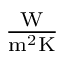Convert formula to latex. <formula><loc_0><loc_0><loc_500><loc_500>{ \frac { W } { m ^ { 2 } K } }</formula> 